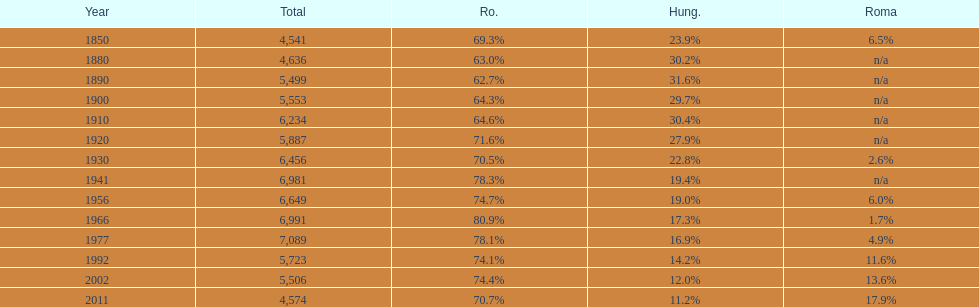What were the total number of times the romanians had a population percentage above 70%? 9. 